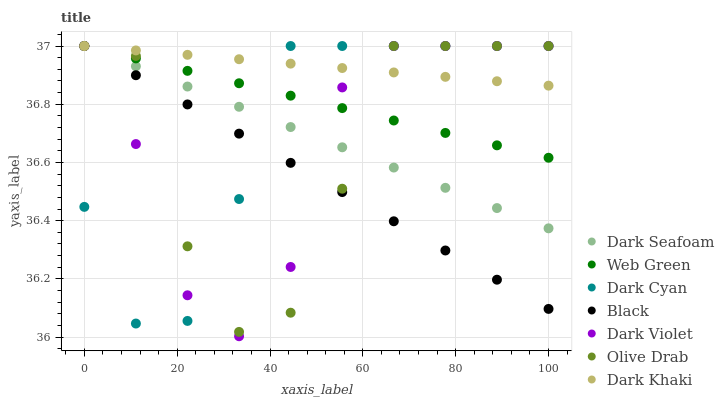Does Black have the minimum area under the curve?
Answer yes or no. Yes. Does Dark Khaki have the maximum area under the curve?
Answer yes or no. Yes. Does Dark Seafoam have the minimum area under the curve?
Answer yes or no. No. Does Dark Seafoam have the maximum area under the curve?
Answer yes or no. No. Is Web Green the smoothest?
Answer yes or no. Yes. Is Olive Drab the roughest?
Answer yes or no. Yes. Is Dark Khaki the smoothest?
Answer yes or no. No. Is Dark Khaki the roughest?
Answer yes or no. No. Does Dark Violet have the lowest value?
Answer yes or no. Yes. Does Dark Seafoam have the lowest value?
Answer yes or no. No. Does Olive Drab have the highest value?
Answer yes or no. Yes. Does Dark Cyan intersect Olive Drab?
Answer yes or no. Yes. Is Dark Cyan less than Olive Drab?
Answer yes or no. No. Is Dark Cyan greater than Olive Drab?
Answer yes or no. No. 